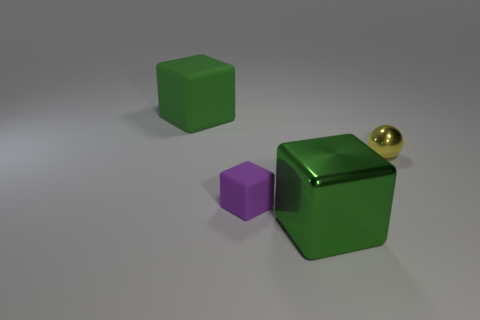Add 4 tiny brown blocks. How many objects exist? 8 Subtract all cubes. How many objects are left? 1 Add 1 small balls. How many small balls exist? 2 Subtract 0 red balls. How many objects are left? 4 Subtract all tiny purple rubber things. Subtract all large cubes. How many objects are left? 1 Add 2 green shiny blocks. How many green shiny blocks are left? 3 